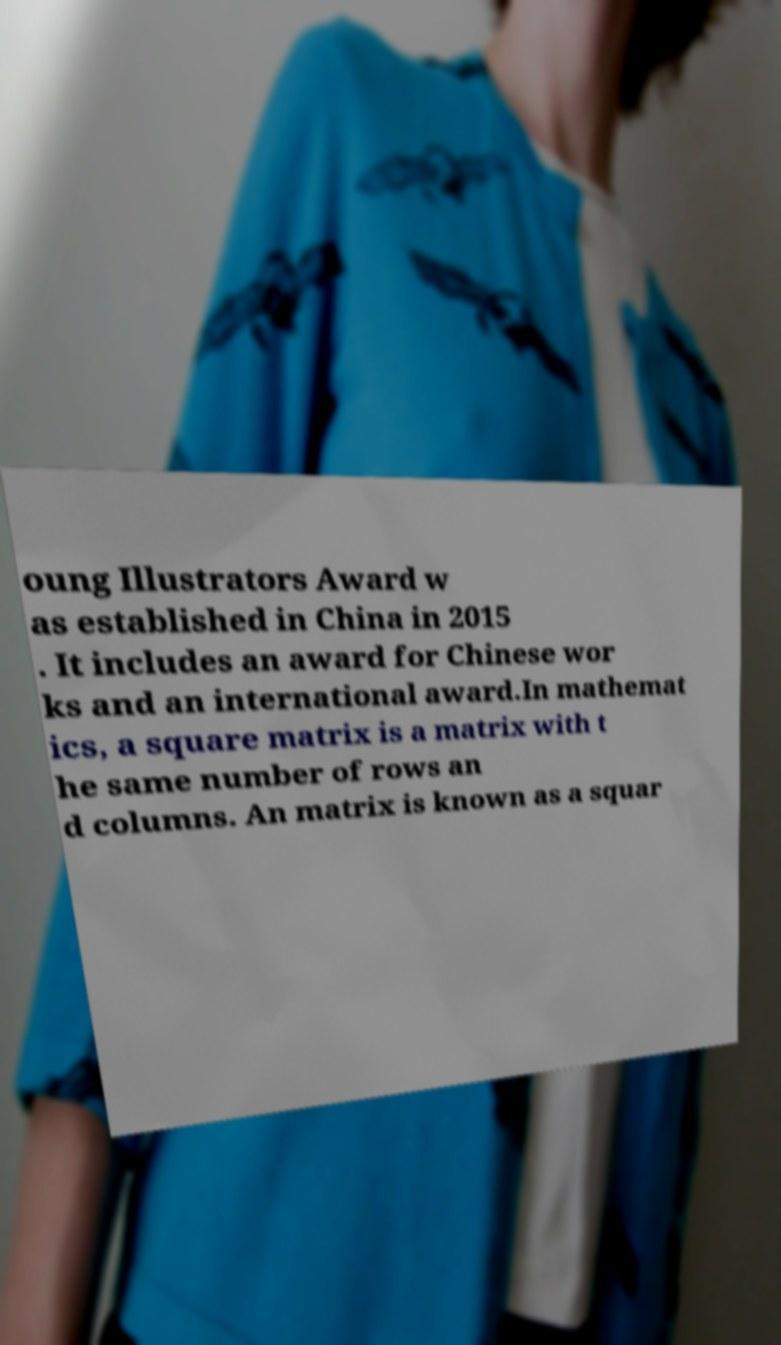Please identify and transcribe the text found in this image. oung Illustrators Award w as established in China in 2015 . It includes an award for Chinese wor ks and an international award.In mathemat ics, a square matrix is a matrix with t he same number of rows an d columns. An matrix is known as a squar 